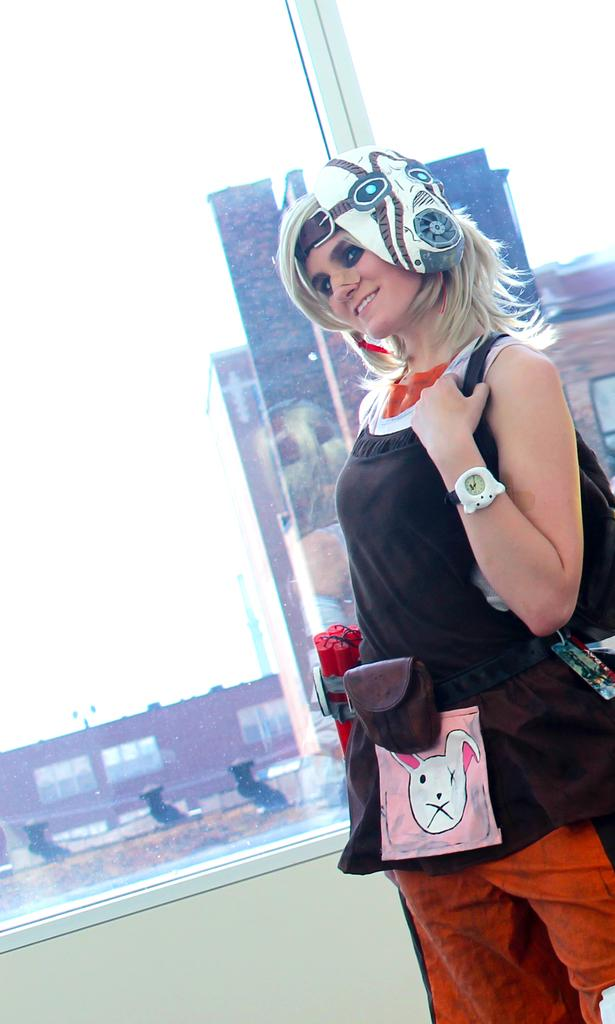What is the woman doing in the image? The woman is standing on the ground on the right side of the image. What can be seen in the distance behind the woman? There are buildings, a window, and a wall in the background of the image. What is visible in the sky in the image? The sky is visible in the background of the image. What type of celery is being cooked in the oven in the image? There is no oven or celery present in the image. 